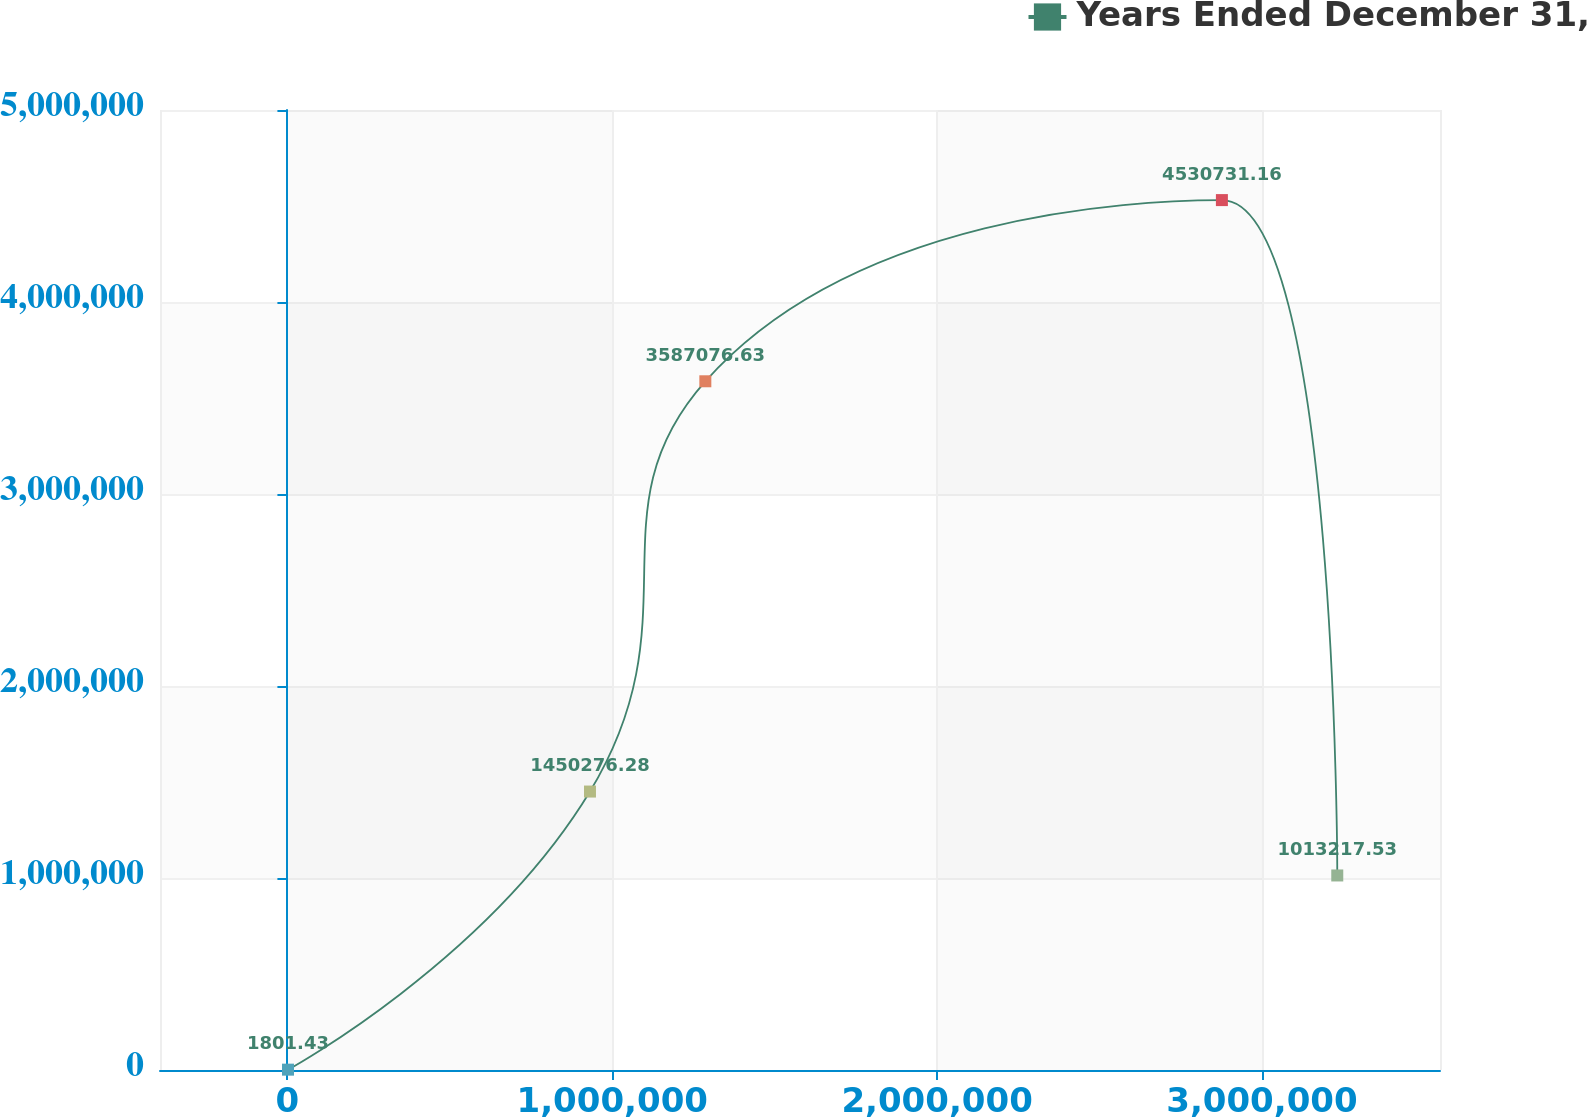<chart> <loc_0><loc_0><loc_500><loc_500><line_chart><ecel><fcel>Years Ended December 31,<nl><fcel>1787.77<fcel>1801.43<nl><fcel>931373<fcel>1.45028e+06<nl><fcel>1.28652e+06<fcel>3.58708e+06<nl><fcel>2.87672e+06<fcel>4.53073e+06<nl><fcel>3.23186e+06<fcel>1.01322e+06<nl><fcel>3.587e+06<fcel>3.15002e+06<nl><fcel>3.94215e+06<fcel>4.09367e+06<nl></chart> 